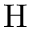Convert formula to latex. <formula><loc_0><loc_0><loc_500><loc_500>H</formula> 